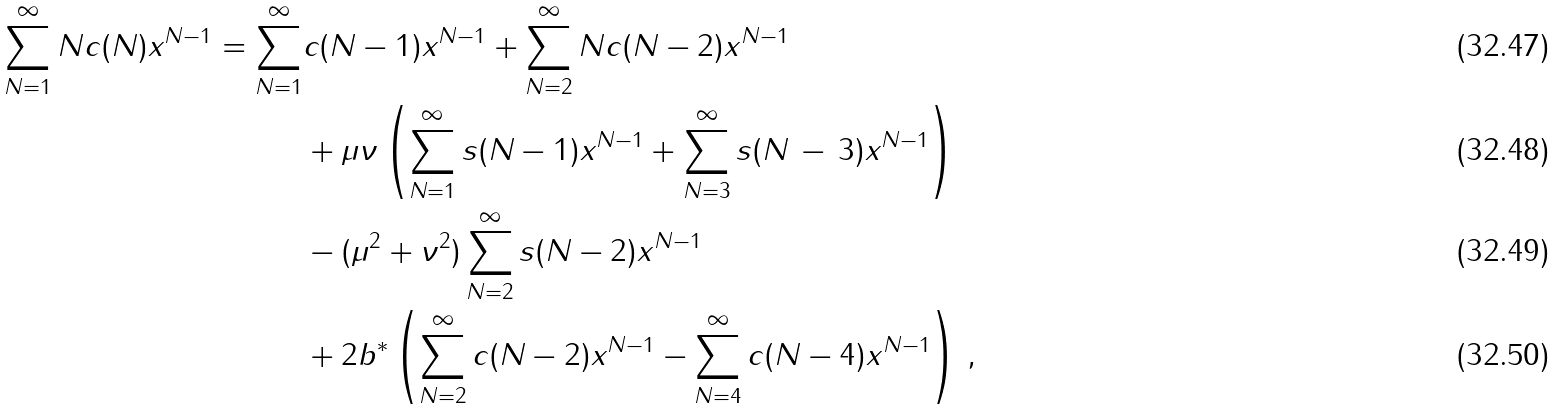Convert formula to latex. <formula><loc_0><loc_0><loc_500><loc_500>\sum _ { N = 1 } ^ { \infty } N c ( N ) x ^ { N - 1 } = \sum _ { N = 1 } ^ { \infty } & c ( N - 1 ) x ^ { N - 1 } + \sum _ { N = 2 } ^ { \infty } N c ( N - 2 ) x ^ { N - 1 } \\ & + \mu \nu \left ( \sum _ { N = 1 } ^ { \infty } s ( N - 1 ) x ^ { N - 1 } + \sum _ { N = 3 } ^ { \infty } s ( N \, - \, 3 ) x ^ { N - 1 } \right ) \\ & - ( \mu ^ { 2 } + \nu ^ { 2 } ) \sum _ { N = 2 } ^ { \infty } s ( N - 2 ) x ^ { N - 1 } \\ & + 2 b ^ { * } \left ( \sum _ { N = 2 } ^ { \infty } c ( N - 2 ) x ^ { N - 1 } - \sum _ { N = 4 } ^ { \infty } c ( N - 4 ) x ^ { N - 1 } \right ) \, ,</formula> 